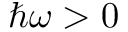<formula> <loc_0><loc_0><loc_500><loc_500>\hbar { \omega } > 0</formula> 